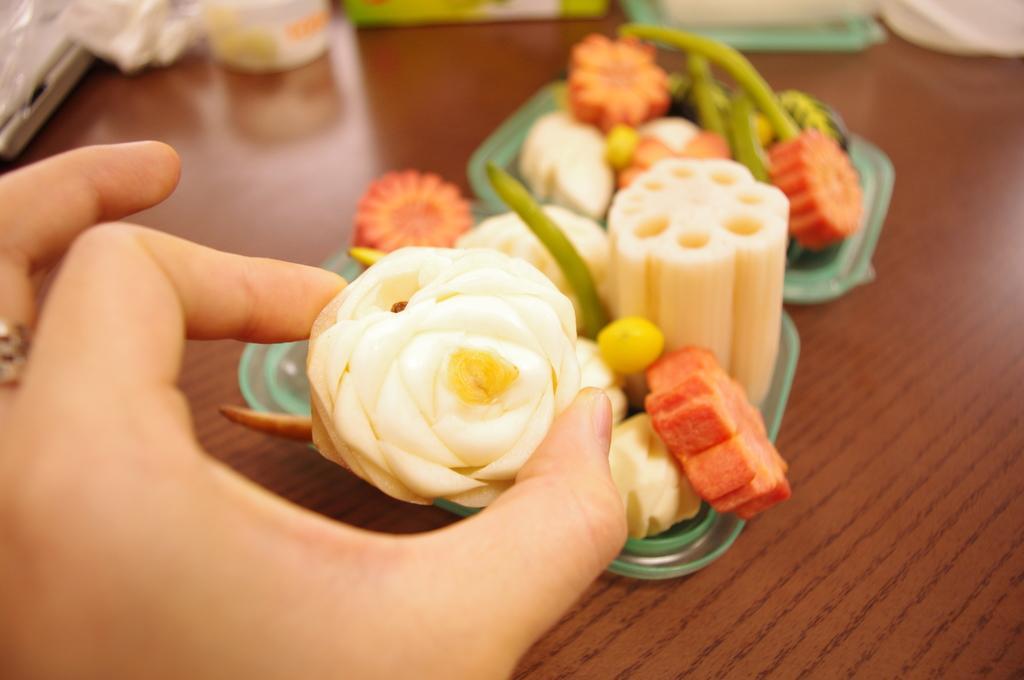How would you summarize this image in a sentence or two? As we can see in the image there is a table and human hand. On table there are plates. In plates there are sweets. 